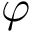<formula> <loc_0><loc_0><loc_500><loc_500>\varphi</formula> 